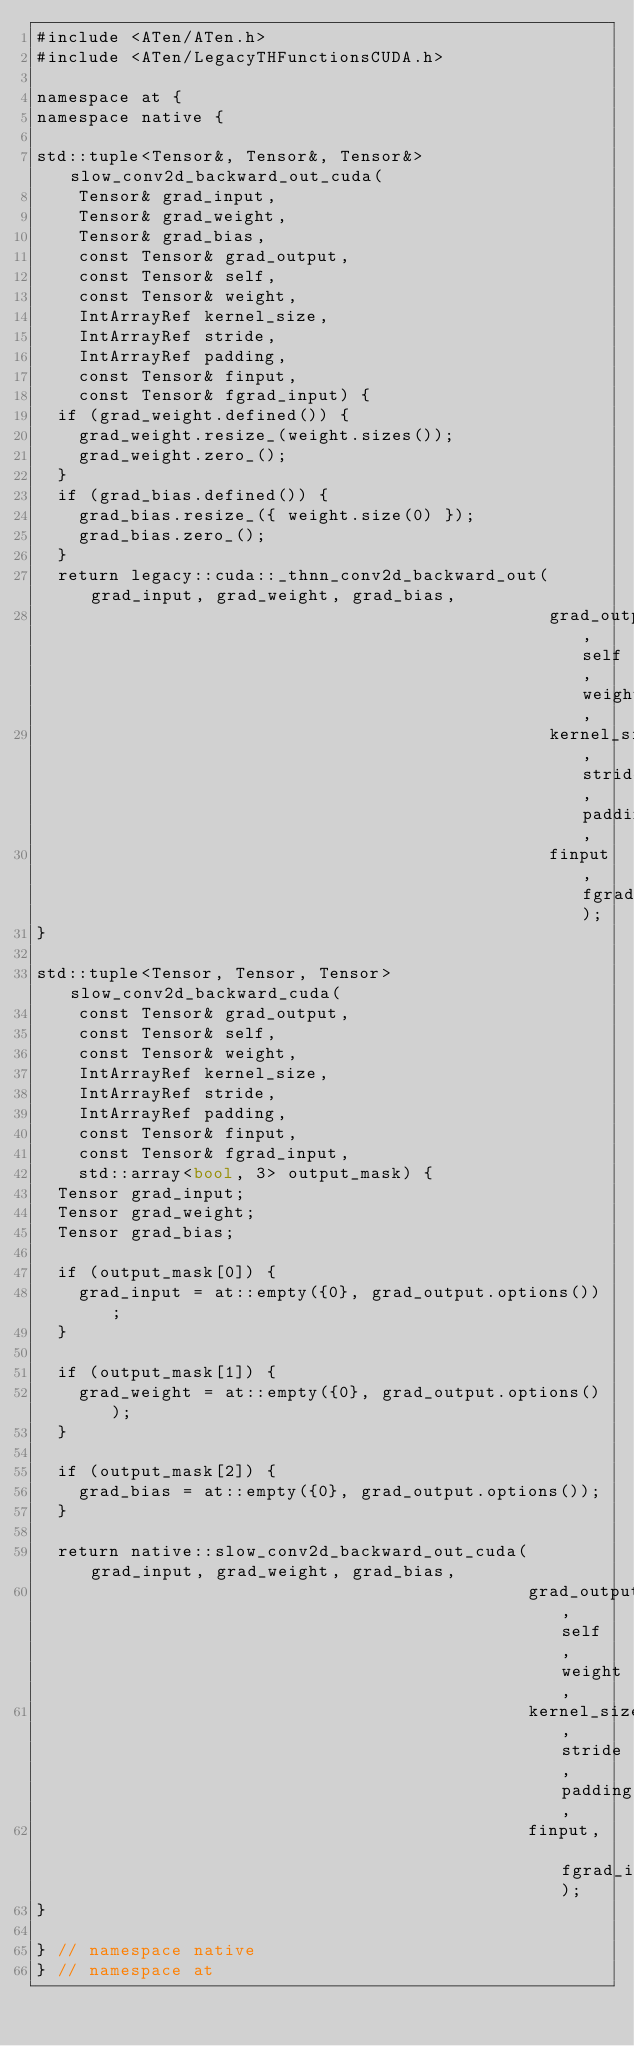<code> <loc_0><loc_0><loc_500><loc_500><_Cuda_>#include <ATen/ATen.h>
#include <ATen/LegacyTHFunctionsCUDA.h>

namespace at {
namespace native {

std::tuple<Tensor&, Tensor&, Tensor&> slow_conv2d_backward_out_cuda(
    Tensor& grad_input,
    Tensor& grad_weight,
    Tensor& grad_bias,
    const Tensor& grad_output,
    const Tensor& self,
    const Tensor& weight,
    IntArrayRef kernel_size,
    IntArrayRef stride,
    IntArrayRef padding,
    const Tensor& finput,
    const Tensor& fgrad_input) {
  if (grad_weight.defined()) {
    grad_weight.resize_(weight.sizes());
    grad_weight.zero_();
  }
  if (grad_bias.defined()) {
    grad_bias.resize_({ weight.size(0) });
    grad_bias.zero_();
  }
  return legacy::cuda::_thnn_conv2d_backward_out(grad_input, grad_weight, grad_bias,
                                                 grad_output, self, weight,
                                                 kernel_size, stride, padding,
                                                 finput, fgrad_input);
}

std::tuple<Tensor, Tensor, Tensor> slow_conv2d_backward_cuda(
    const Tensor& grad_output,
    const Tensor& self,
    const Tensor& weight,
    IntArrayRef kernel_size,
    IntArrayRef stride,
    IntArrayRef padding,
    const Tensor& finput,
    const Tensor& fgrad_input,
    std::array<bool, 3> output_mask) {
  Tensor grad_input;
  Tensor grad_weight;
  Tensor grad_bias;

  if (output_mask[0]) {
    grad_input = at::empty({0}, grad_output.options());
  }

  if (output_mask[1]) {
    grad_weight = at::empty({0}, grad_output.options());
  }

  if (output_mask[2]) {
    grad_bias = at::empty({0}, grad_output.options());
  }

  return native::slow_conv2d_backward_out_cuda(grad_input, grad_weight, grad_bias,
                                               grad_output, self, weight,
                                               kernel_size, stride, padding,
                                               finput, fgrad_input);
}

} // namespace native
} // namespace at
</code> 